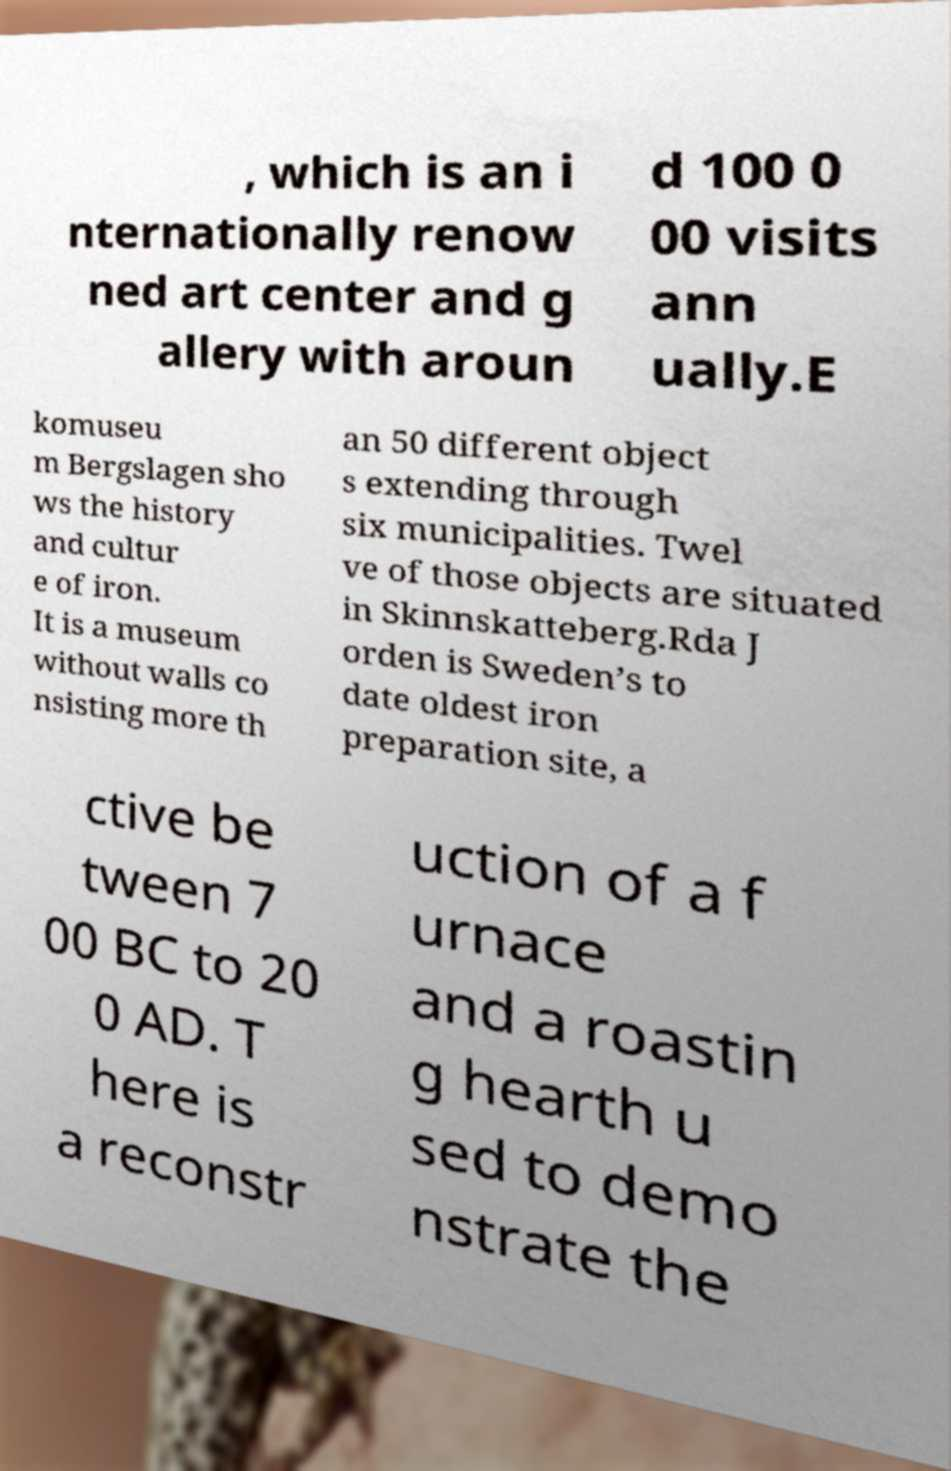For documentation purposes, I need the text within this image transcribed. Could you provide that? , which is an i nternationally renow ned art center and g allery with aroun d 100 0 00 visits ann ually.E komuseu m Bergslagen sho ws the history and cultur e of iron. It is a museum without walls co nsisting more th an 50 different object s extending through six municipalities. Twel ve of those objects are situated in Skinnskatteberg.Rda J orden is Sweden’s to date oldest iron preparation site, a ctive be tween 7 00 BC to 20 0 AD. T here is a reconstr uction of a f urnace and a roastin g hearth u sed to demo nstrate the 